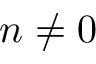<formula> <loc_0><loc_0><loc_500><loc_500>n \ne 0</formula> 